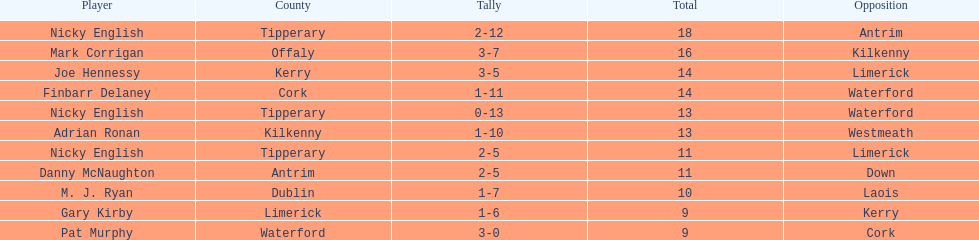How many people are on the list? 9. I'm looking to parse the entire table for insights. Could you assist me with that? {'header': ['Player', 'County', 'Tally', 'Total', 'Opposition'], 'rows': [['Nicky English', 'Tipperary', '2-12', '18', 'Antrim'], ['Mark Corrigan', 'Offaly', '3-7', '16', 'Kilkenny'], ['Joe Hennessy', 'Kerry', '3-5', '14', 'Limerick'], ['Finbarr Delaney', 'Cork', '1-11', '14', 'Waterford'], ['Nicky English', 'Tipperary', '0-13', '13', 'Waterford'], ['Adrian Ronan', 'Kilkenny', '1-10', '13', 'Westmeath'], ['Nicky English', 'Tipperary', '2-5', '11', 'Limerick'], ['Danny McNaughton', 'Antrim', '2-5', '11', 'Down'], ['M. J. Ryan', 'Dublin', '1-7', '10', 'Laois'], ['Gary Kirby', 'Limerick', '1-6', '9', 'Kerry'], ['Pat Murphy', 'Waterford', '3-0', '9', 'Cork']]} 